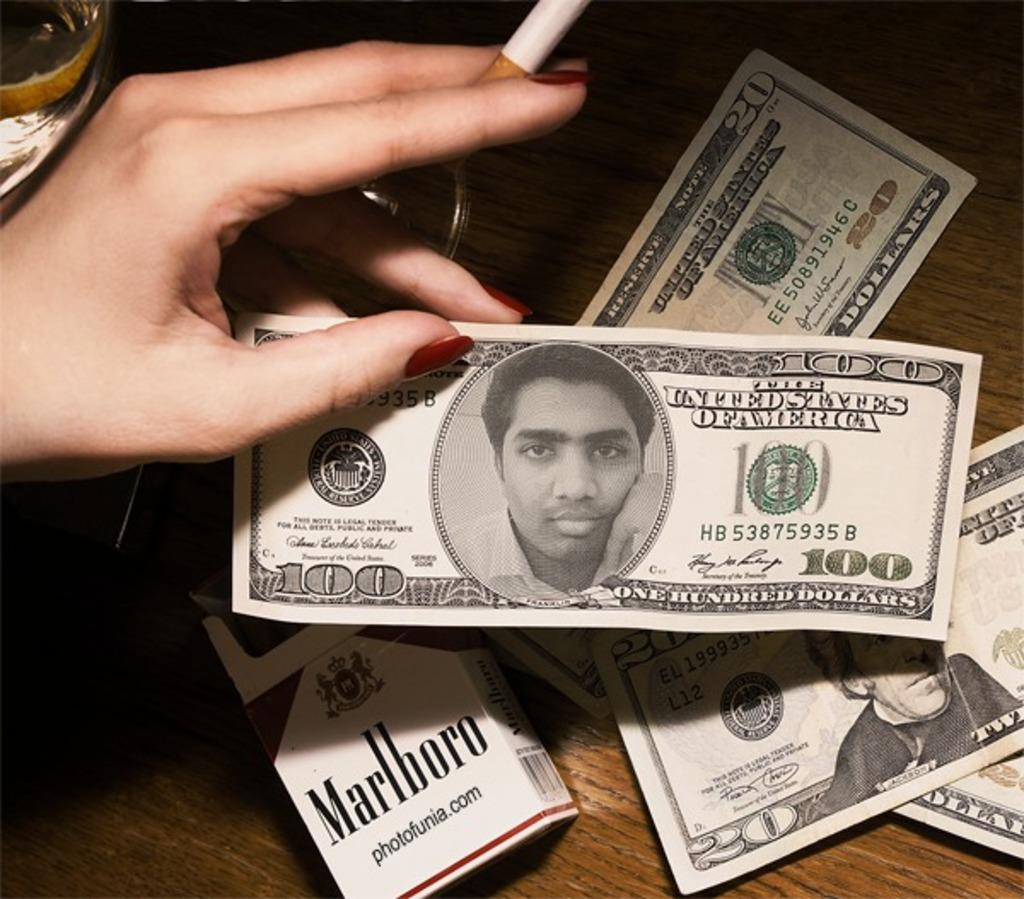Provide a one-sentence caption for the provided image. Box of Marlboro cigarettes and three twenty dollar bills plus a one hundred bill. 